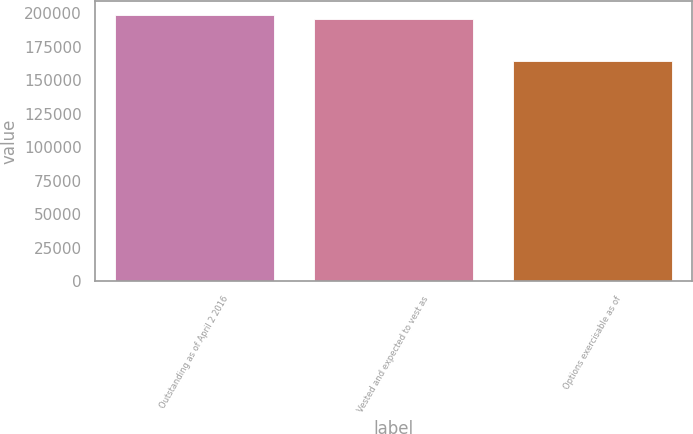<chart> <loc_0><loc_0><loc_500><loc_500><bar_chart><fcel>Outstanding as of April 2 2016<fcel>Vested and expected to vest as<fcel>Options exercisable as of<nl><fcel>198848<fcel>195663<fcel>164364<nl></chart> 